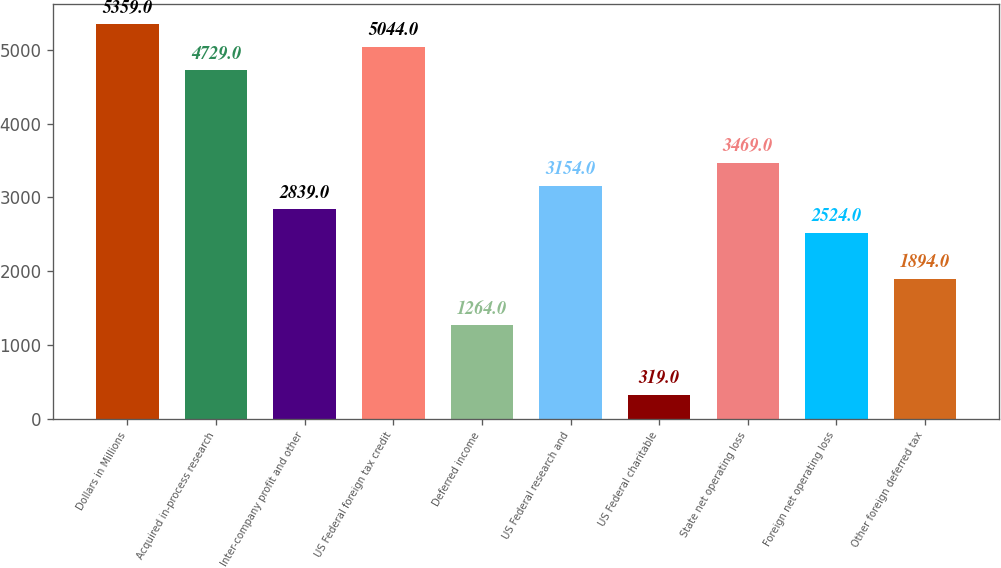<chart> <loc_0><loc_0><loc_500><loc_500><bar_chart><fcel>Dollars in Millions<fcel>Acquired in-process research<fcel>Inter-company profit and other<fcel>US Federal foreign tax credit<fcel>Deferred income<fcel>US Federal research and<fcel>US Federal charitable<fcel>State net operating loss<fcel>Foreign net operating loss<fcel>Other foreign deferred tax<nl><fcel>5359<fcel>4729<fcel>2839<fcel>5044<fcel>1264<fcel>3154<fcel>319<fcel>3469<fcel>2524<fcel>1894<nl></chart> 